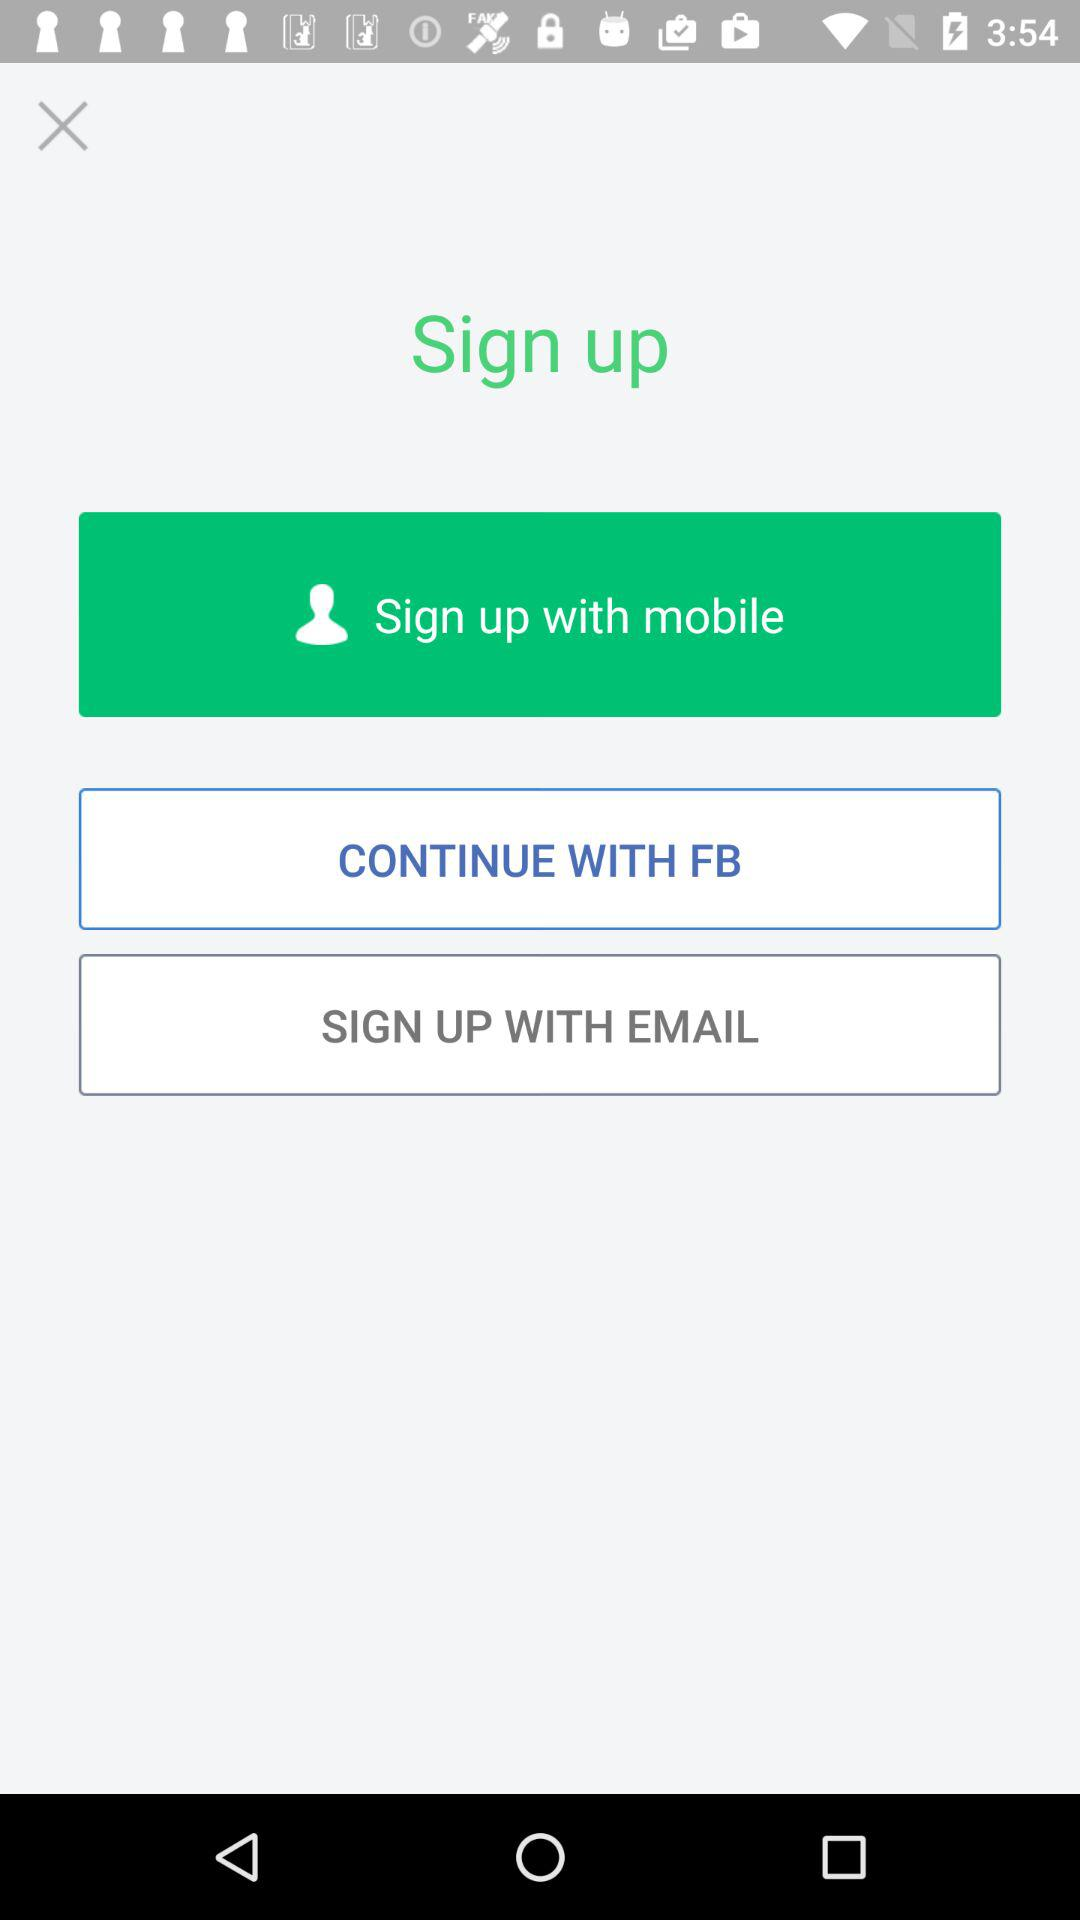What accounts can I use to sign up? You can use "mobile", "FB" and "EMAIL" to sign up. 